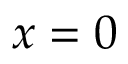Convert formula to latex. <formula><loc_0><loc_0><loc_500><loc_500>x = 0</formula> 